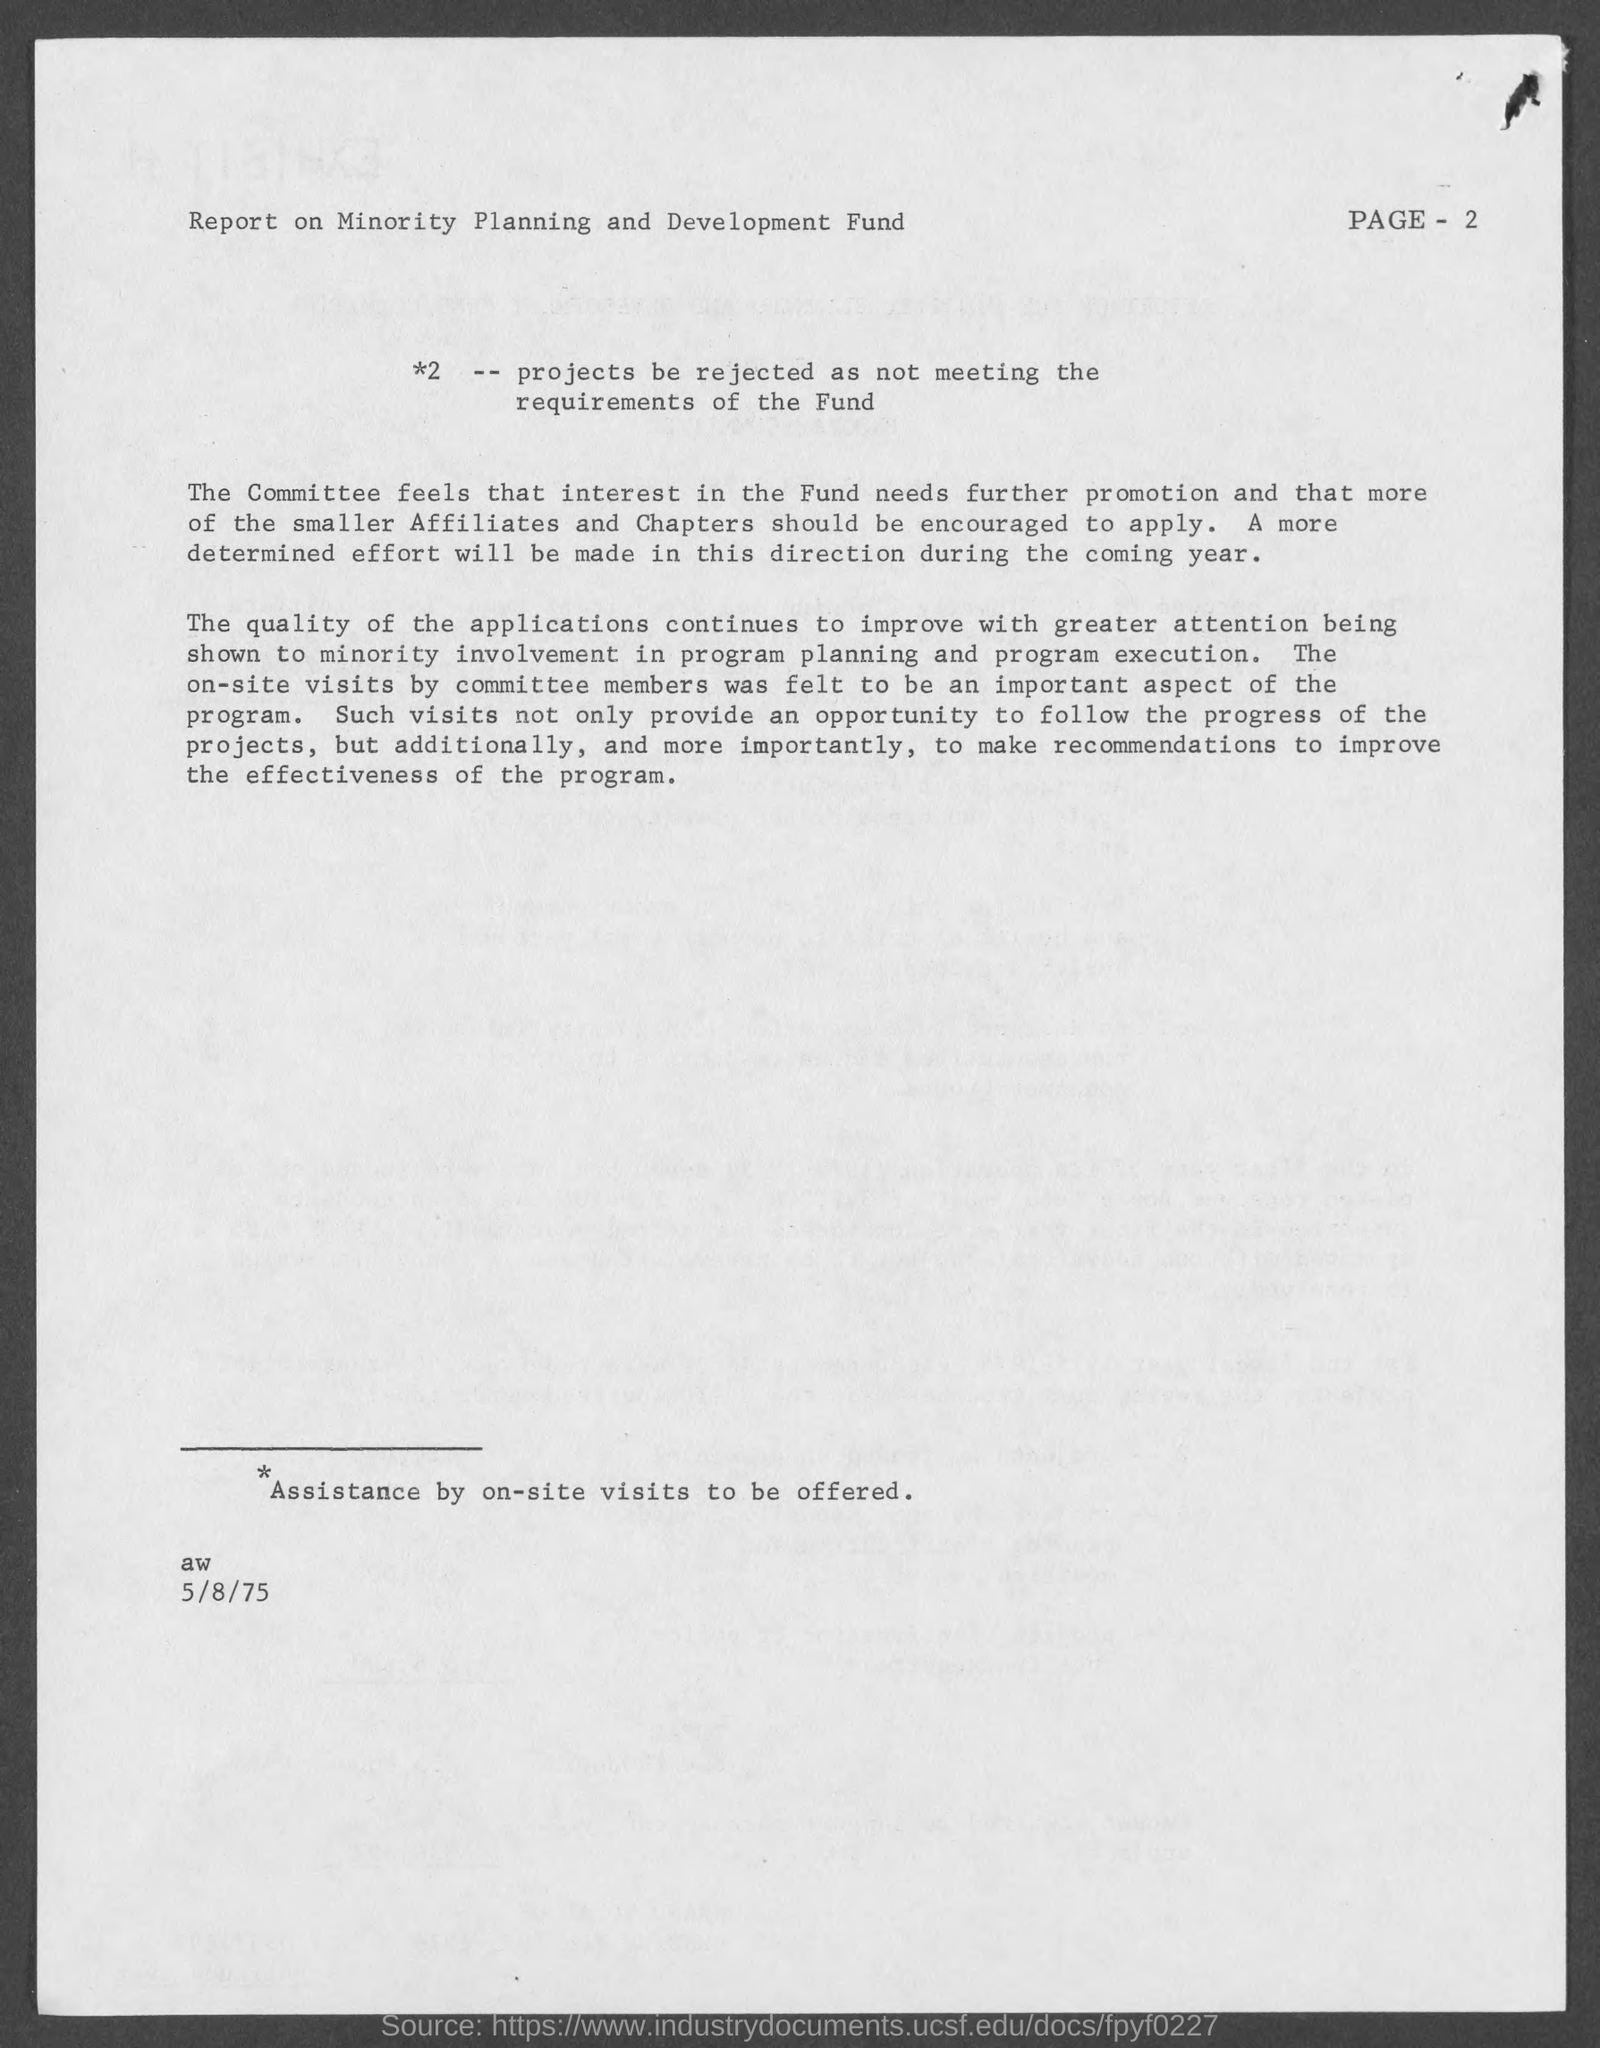List a handful of essential elements in this visual. The date mentioned in this document is May 8th, 1975. 